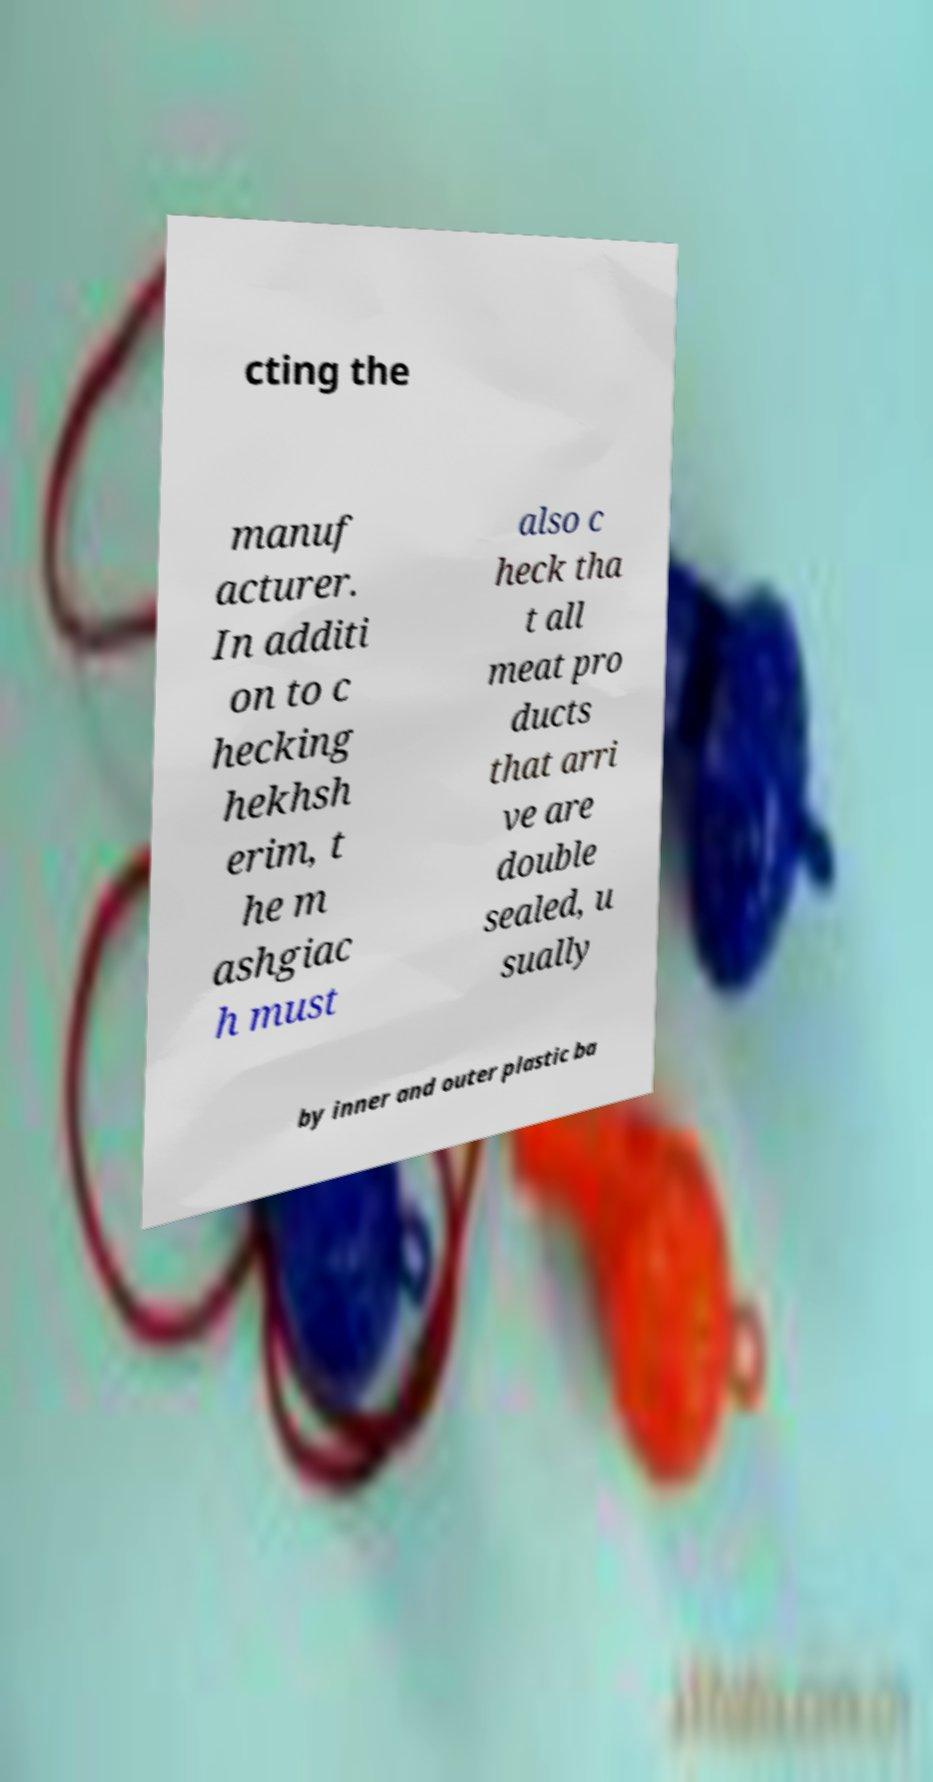Could you extract and type out the text from this image? cting the manuf acturer. In additi on to c hecking hekhsh erim, t he m ashgiac h must also c heck tha t all meat pro ducts that arri ve are double sealed, u sually by inner and outer plastic ba 